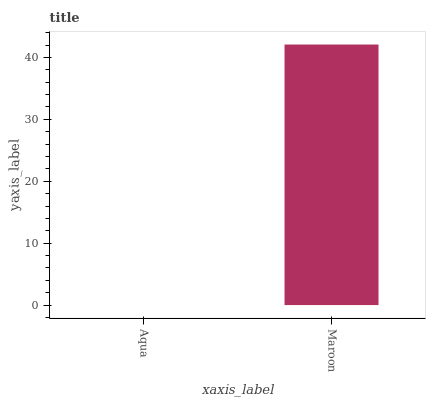Is Aqua the minimum?
Answer yes or no. Yes. Is Maroon the maximum?
Answer yes or no. Yes. Is Maroon the minimum?
Answer yes or no. No. Is Maroon greater than Aqua?
Answer yes or no. Yes. Is Aqua less than Maroon?
Answer yes or no. Yes. Is Aqua greater than Maroon?
Answer yes or no. No. Is Maroon less than Aqua?
Answer yes or no. No. Is Maroon the high median?
Answer yes or no. Yes. Is Aqua the low median?
Answer yes or no. Yes. Is Aqua the high median?
Answer yes or no. No. Is Maroon the low median?
Answer yes or no. No. 